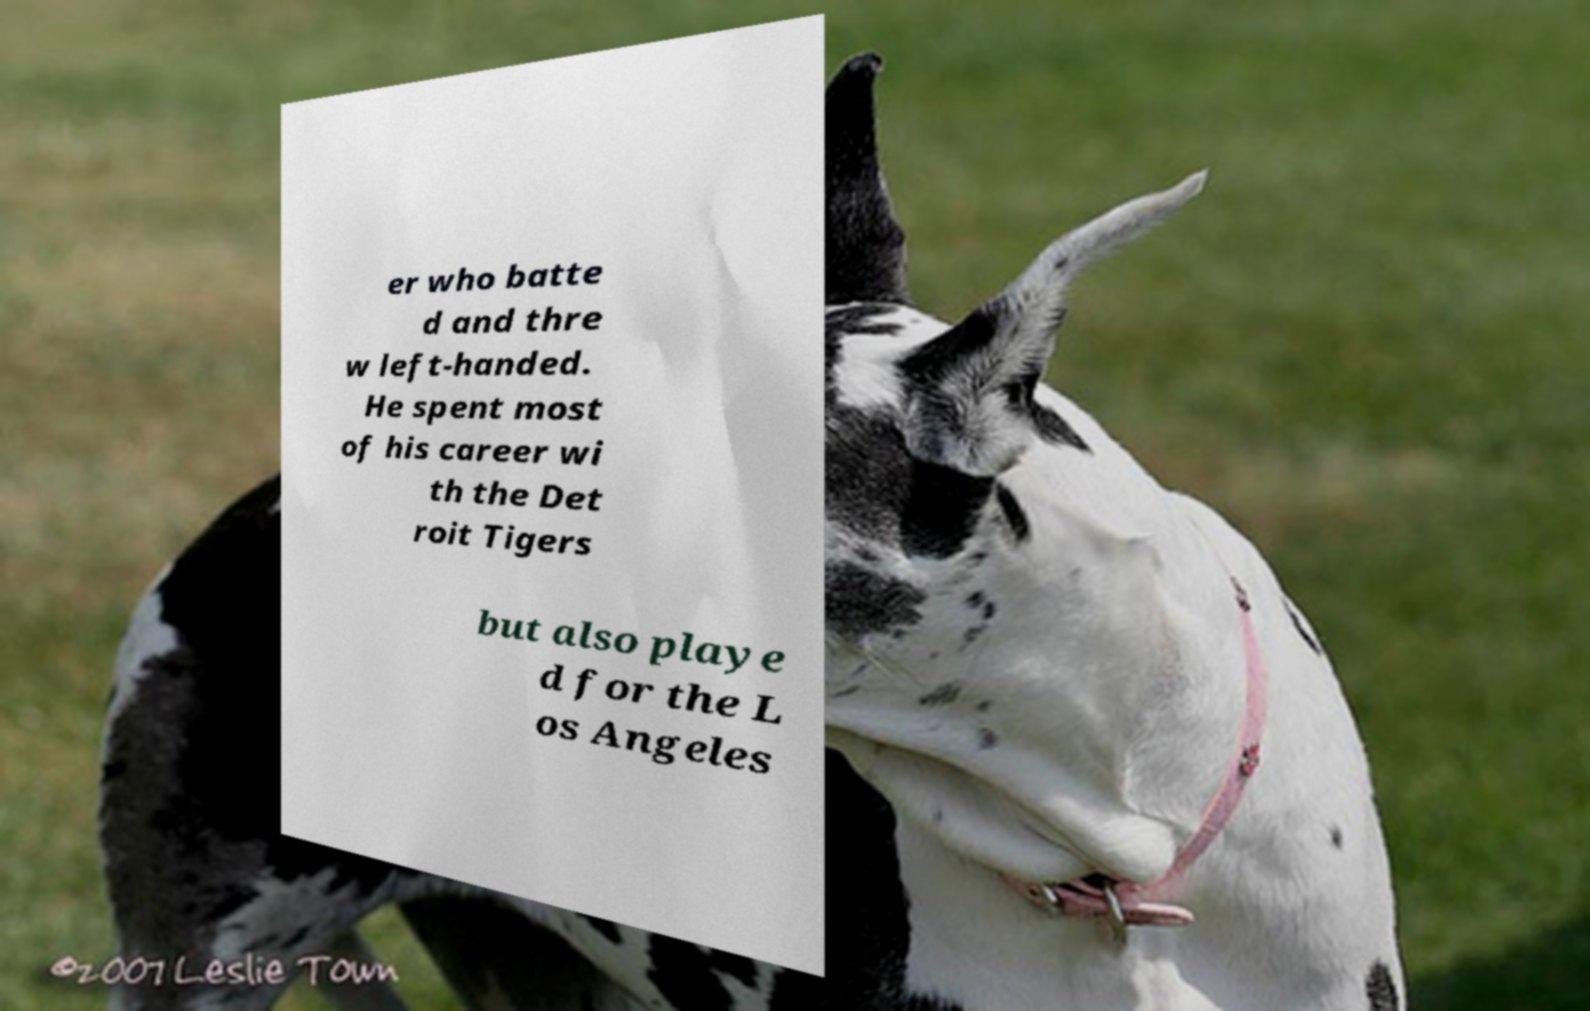I need the written content from this picture converted into text. Can you do that? er who batte d and thre w left-handed. He spent most of his career wi th the Det roit Tigers but also playe d for the L os Angeles 